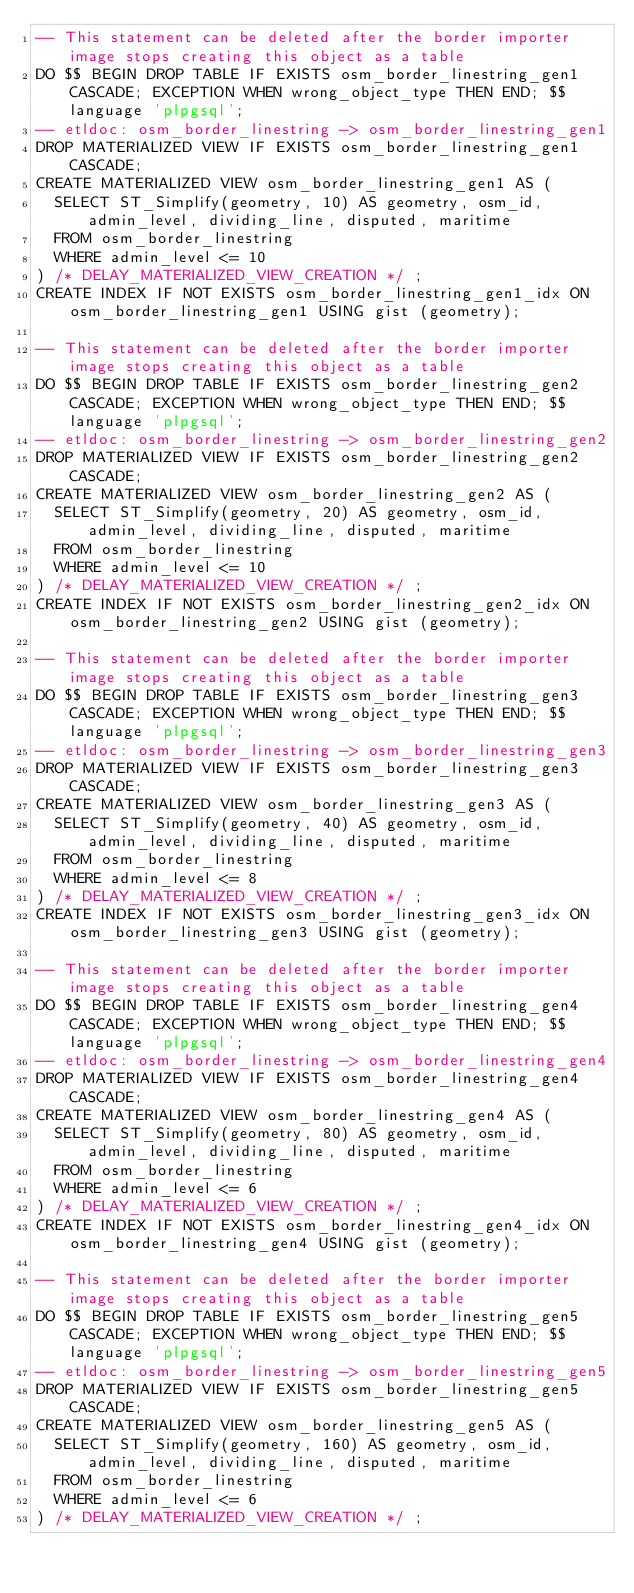<code> <loc_0><loc_0><loc_500><loc_500><_SQL_>-- This statement can be deleted after the border importer image stops creating this object as a table
DO $$ BEGIN DROP TABLE IF EXISTS osm_border_linestring_gen1 CASCADE; EXCEPTION WHEN wrong_object_type THEN END; $$ language 'plpgsql';
-- etldoc: osm_border_linestring -> osm_border_linestring_gen1
DROP MATERIALIZED VIEW IF EXISTS osm_border_linestring_gen1 CASCADE;
CREATE MATERIALIZED VIEW osm_border_linestring_gen1 AS (
  SELECT ST_Simplify(geometry, 10) AS geometry, osm_id, admin_level, dividing_line, disputed, maritime
  FROM osm_border_linestring
  WHERE admin_level <= 10
) /* DELAY_MATERIALIZED_VIEW_CREATION */ ;
CREATE INDEX IF NOT EXISTS osm_border_linestring_gen1_idx ON osm_border_linestring_gen1 USING gist (geometry);

-- This statement can be deleted after the border importer image stops creating this object as a table
DO $$ BEGIN DROP TABLE IF EXISTS osm_border_linestring_gen2 CASCADE; EXCEPTION WHEN wrong_object_type THEN END; $$ language 'plpgsql';
-- etldoc: osm_border_linestring -> osm_border_linestring_gen2
DROP MATERIALIZED VIEW IF EXISTS osm_border_linestring_gen2 CASCADE;
CREATE MATERIALIZED VIEW osm_border_linestring_gen2 AS (
  SELECT ST_Simplify(geometry, 20) AS geometry, osm_id, admin_level, dividing_line, disputed, maritime
  FROM osm_border_linestring
  WHERE admin_level <= 10
) /* DELAY_MATERIALIZED_VIEW_CREATION */ ;
CREATE INDEX IF NOT EXISTS osm_border_linestring_gen2_idx ON osm_border_linestring_gen2 USING gist (geometry);

-- This statement can be deleted after the border importer image stops creating this object as a table
DO $$ BEGIN DROP TABLE IF EXISTS osm_border_linestring_gen3 CASCADE; EXCEPTION WHEN wrong_object_type THEN END; $$ language 'plpgsql';
-- etldoc: osm_border_linestring -> osm_border_linestring_gen3
DROP MATERIALIZED VIEW IF EXISTS osm_border_linestring_gen3 CASCADE;
CREATE MATERIALIZED VIEW osm_border_linestring_gen3 AS (
  SELECT ST_Simplify(geometry, 40) AS geometry, osm_id, admin_level, dividing_line, disputed, maritime
  FROM osm_border_linestring
  WHERE admin_level <= 8
) /* DELAY_MATERIALIZED_VIEW_CREATION */ ;
CREATE INDEX IF NOT EXISTS osm_border_linestring_gen3_idx ON osm_border_linestring_gen3 USING gist (geometry);

-- This statement can be deleted after the border importer image stops creating this object as a table
DO $$ BEGIN DROP TABLE IF EXISTS osm_border_linestring_gen4 CASCADE; EXCEPTION WHEN wrong_object_type THEN END; $$ language 'plpgsql';
-- etldoc: osm_border_linestring -> osm_border_linestring_gen4
DROP MATERIALIZED VIEW IF EXISTS osm_border_linestring_gen4 CASCADE;
CREATE MATERIALIZED VIEW osm_border_linestring_gen4 AS (
  SELECT ST_Simplify(geometry, 80) AS geometry, osm_id, admin_level, dividing_line, disputed, maritime
  FROM osm_border_linestring
  WHERE admin_level <= 6
) /* DELAY_MATERIALIZED_VIEW_CREATION */ ;
CREATE INDEX IF NOT EXISTS osm_border_linestring_gen4_idx ON osm_border_linestring_gen4 USING gist (geometry);

-- This statement can be deleted after the border importer image stops creating this object as a table
DO $$ BEGIN DROP TABLE IF EXISTS osm_border_linestring_gen5 CASCADE; EXCEPTION WHEN wrong_object_type THEN END; $$ language 'plpgsql';
-- etldoc: osm_border_linestring -> osm_border_linestring_gen5
DROP MATERIALIZED VIEW IF EXISTS osm_border_linestring_gen5 CASCADE;
CREATE MATERIALIZED VIEW osm_border_linestring_gen5 AS (
  SELECT ST_Simplify(geometry, 160) AS geometry, osm_id, admin_level, dividing_line, disputed, maritime
  FROM osm_border_linestring
  WHERE admin_level <= 6
) /* DELAY_MATERIALIZED_VIEW_CREATION */ ;</code> 